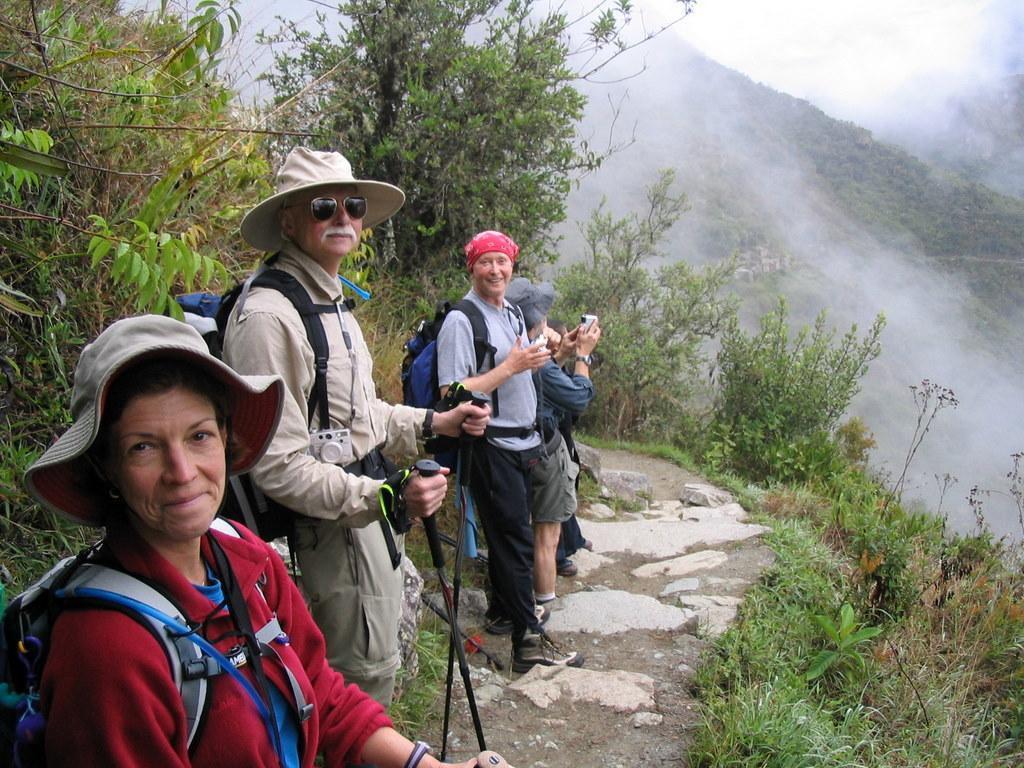What are the people in the image doing? The people in the image are standing on the ground. What is the man holding in the image? The man is holding sticks in the image. What is the other person holding in the image? The other person is holding an object in the image. What can be seen in the background of the image? There are trees, mountains, and the sky visible in the background of the image. What type of door can be seen in the image? There is no door present in the image. Are the people in the image attacking each other? The image does not show any indication of an attack or conflict between the people. 